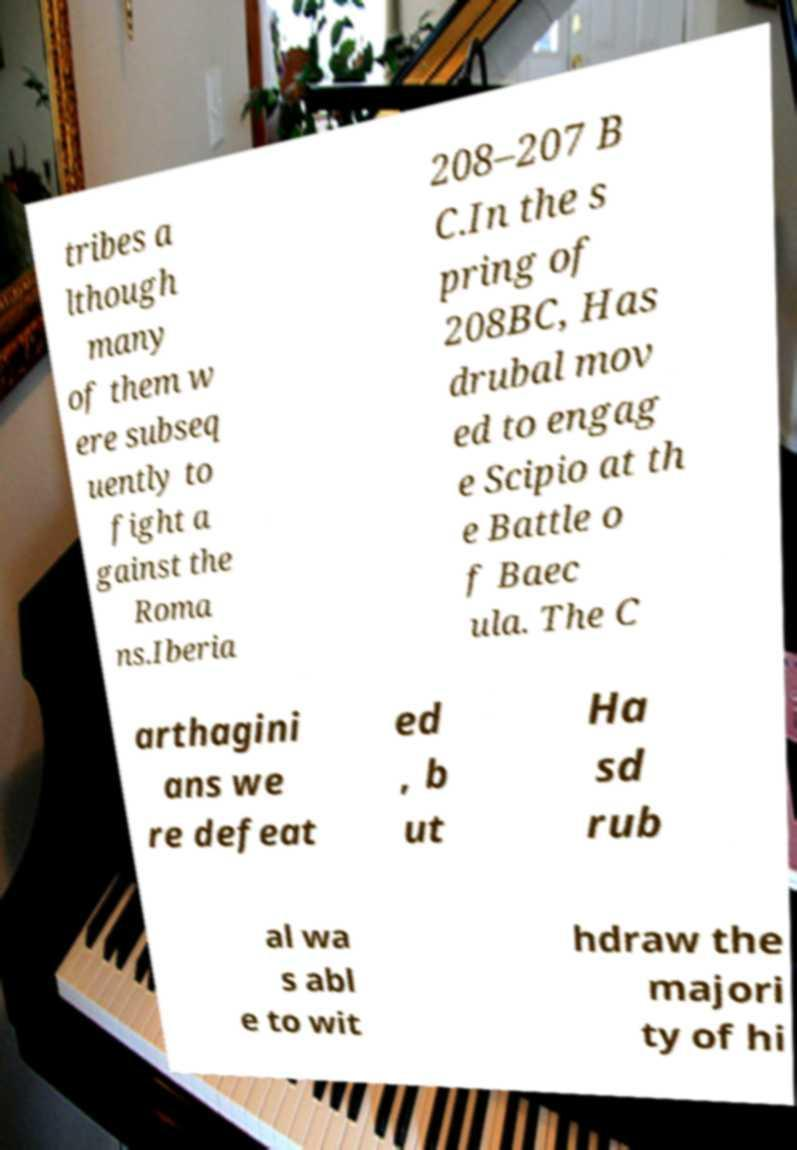There's text embedded in this image that I need extracted. Can you transcribe it verbatim? tribes a lthough many of them w ere subseq uently to fight a gainst the Roma ns.Iberia 208–207 B C.In the s pring of 208BC, Has drubal mov ed to engag e Scipio at th e Battle o f Baec ula. The C arthagini ans we re defeat ed , b ut Ha sd rub al wa s abl e to wit hdraw the majori ty of hi 